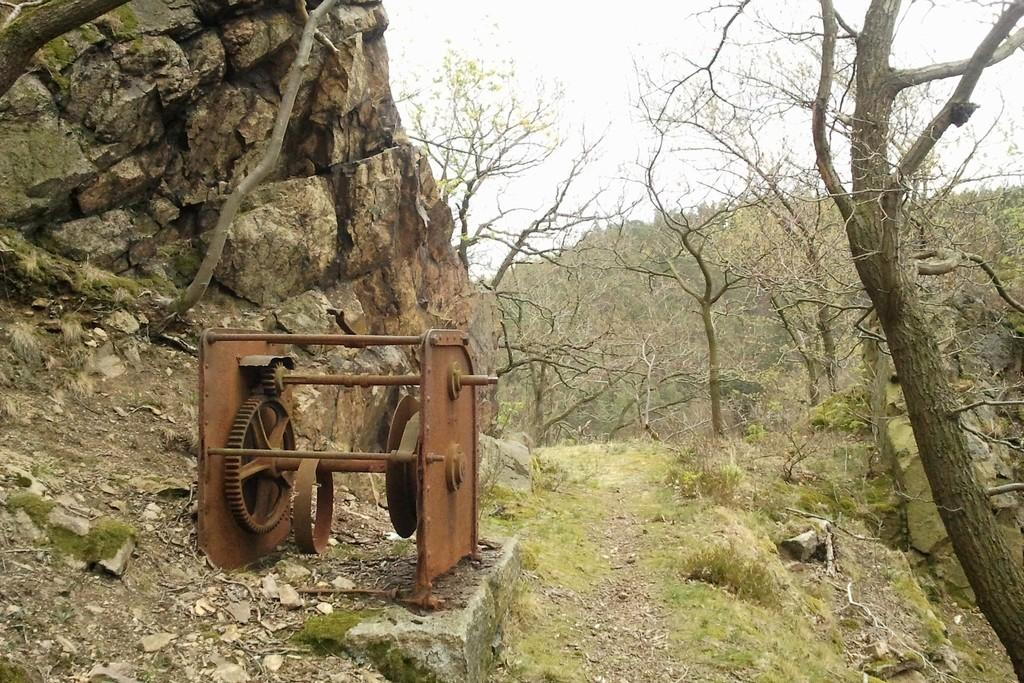What type of object can be seen in the image? There is an iron object in the image. What can be seen in the background of the image? There is a rock and trees in the background of the image. What is visible in the sky in the image? The sky is visible in the image, and it appears to be white in color. How much profit does the scarecrow make in the image? There is no scarecrow present in the image, so it is not possible to determine any profit. 